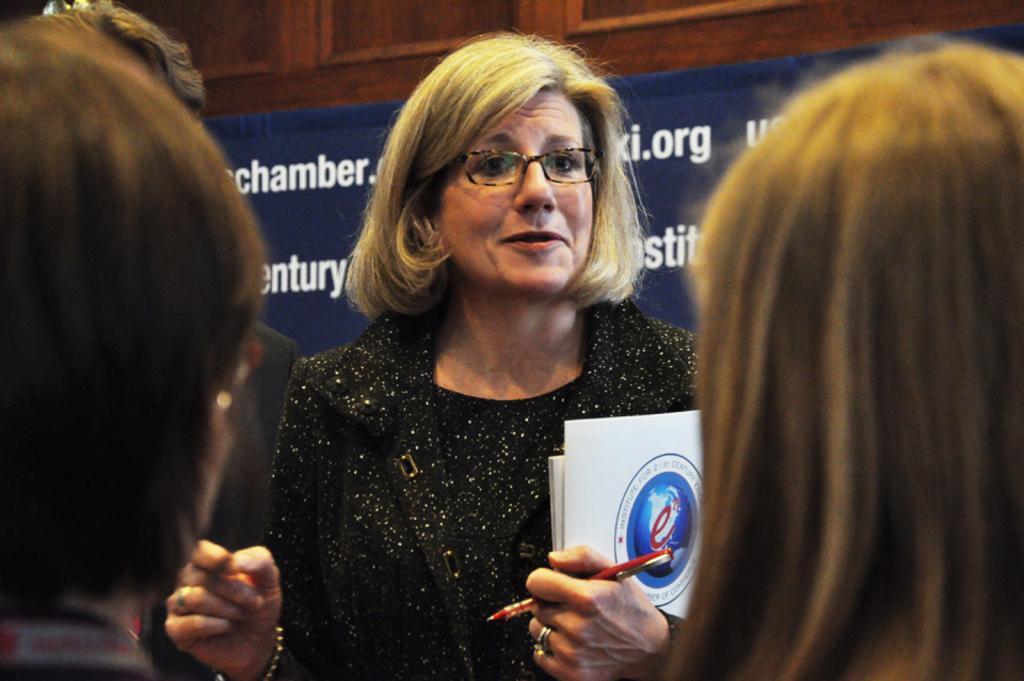Could you give a brief overview of what you see in this image? In this image I can see group of people. In front the person is wearing black color dress and holding few cards and the pen. In the background I can see the banner in blue color and I can see few cupboards in brown color. 